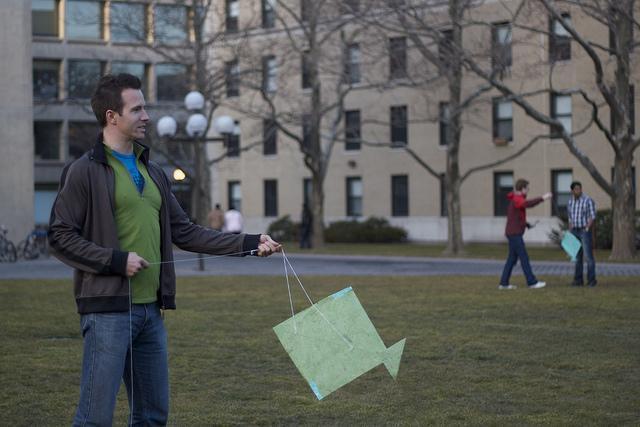How many men are standing on the left?
Give a very brief answer. 1. How many people are there?
Give a very brief answer. 3. 